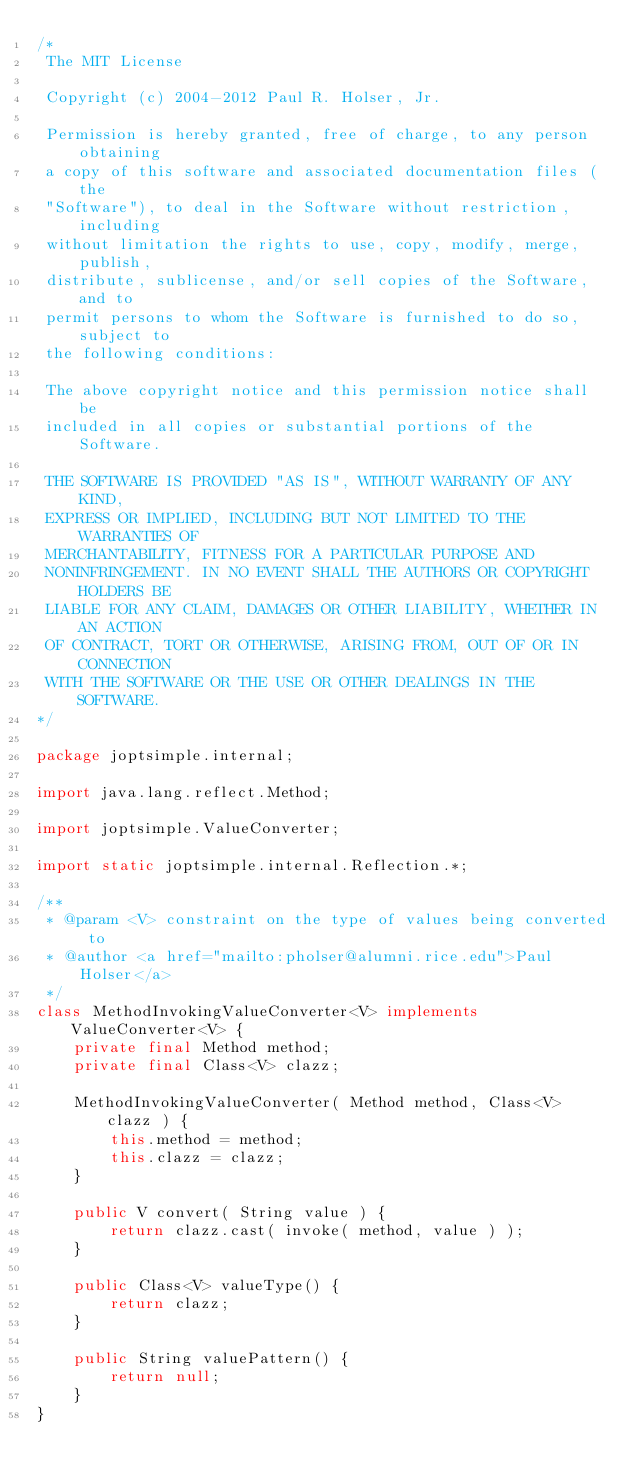Convert code to text. <code><loc_0><loc_0><loc_500><loc_500><_Java_>/*
 The MIT License

 Copyright (c) 2004-2012 Paul R. Holser, Jr.

 Permission is hereby granted, free of charge, to any person obtaining
 a copy of this software and associated documentation files (the
 "Software"), to deal in the Software without restriction, including
 without limitation the rights to use, copy, modify, merge, publish,
 distribute, sublicense, and/or sell copies of the Software, and to
 permit persons to whom the Software is furnished to do so, subject to
 the following conditions:

 The above copyright notice and this permission notice shall be
 included in all copies or substantial portions of the Software.

 THE SOFTWARE IS PROVIDED "AS IS", WITHOUT WARRANTY OF ANY KIND,
 EXPRESS OR IMPLIED, INCLUDING BUT NOT LIMITED TO THE WARRANTIES OF
 MERCHANTABILITY, FITNESS FOR A PARTICULAR PURPOSE AND
 NONINFRINGEMENT. IN NO EVENT SHALL THE AUTHORS OR COPYRIGHT HOLDERS BE
 LIABLE FOR ANY CLAIM, DAMAGES OR OTHER LIABILITY, WHETHER IN AN ACTION
 OF CONTRACT, TORT OR OTHERWISE, ARISING FROM, OUT OF OR IN CONNECTION
 WITH THE SOFTWARE OR THE USE OR OTHER DEALINGS IN THE SOFTWARE.
*/

package joptsimple.internal;

import java.lang.reflect.Method;

import joptsimple.ValueConverter;

import static joptsimple.internal.Reflection.*;

/**
 * @param <V> constraint on the type of values being converted to
 * @author <a href="mailto:pholser@alumni.rice.edu">Paul Holser</a>
 */
class MethodInvokingValueConverter<V> implements ValueConverter<V> {
    private final Method method;
    private final Class<V> clazz;

    MethodInvokingValueConverter( Method method, Class<V> clazz ) {
        this.method = method;
        this.clazz = clazz;
    }

    public V convert( String value ) {
        return clazz.cast( invoke( method, value ) );
    }

    public Class<V> valueType() {
        return clazz;
    }

    public String valuePattern() {
        return null;
    }
}
</code> 